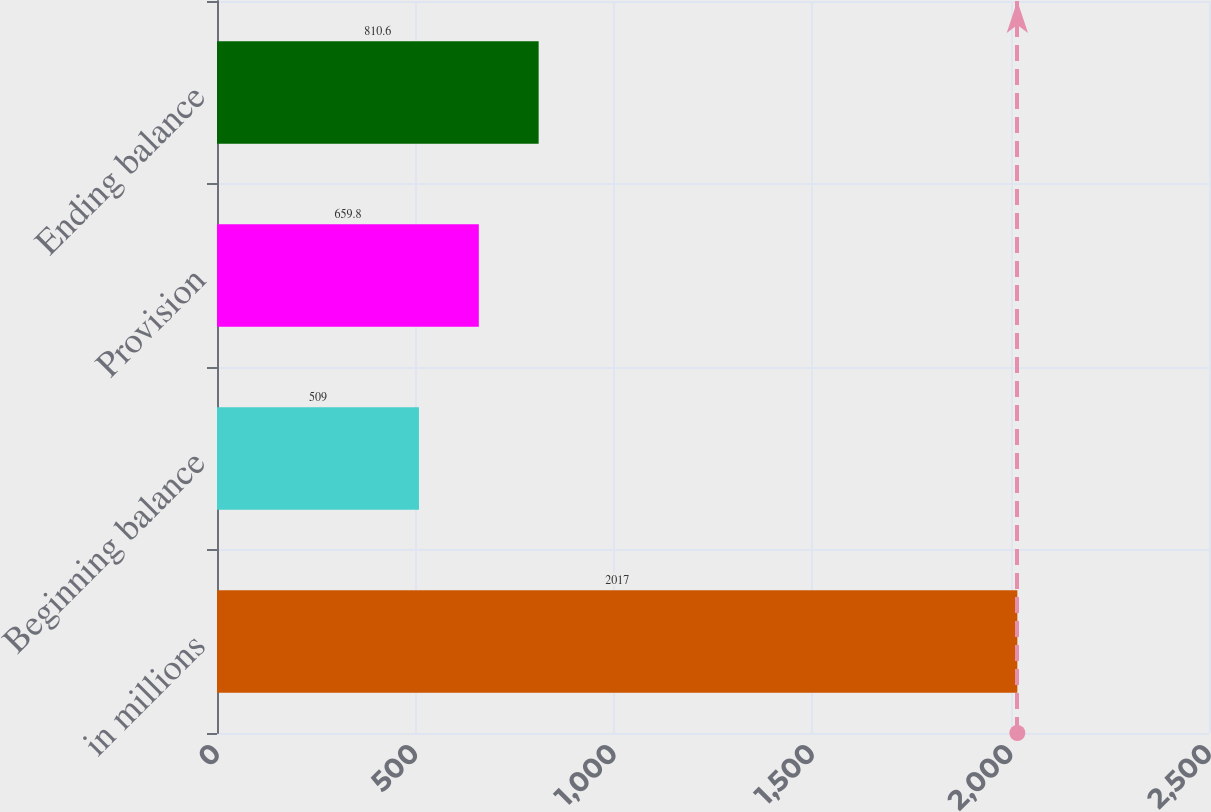Convert chart to OTSL. <chart><loc_0><loc_0><loc_500><loc_500><bar_chart><fcel>in millions<fcel>Beginning balance<fcel>Provision<fcel>Ending balance<nl><fcel>2017<fcel>509<fcel>659.8<fcel>810.6<nl></chart> 